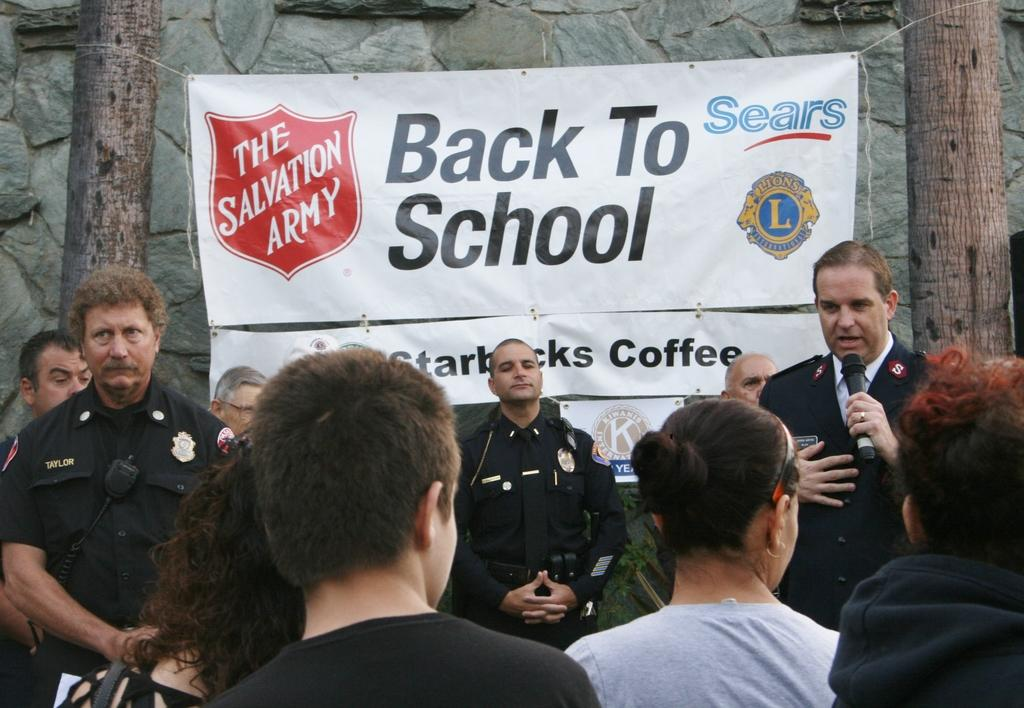How many people are in the image? There is a group of people in the image. What is the man holding among the group doing? The man holding a microphone among the group is likely speaking or performing. What can be seen in the background of the image? There is a banner, tree trunks, and a wall visible in the background of the image. Where is the badge located in the image? There is no badge present in the image. How does the group of people slip down the cellar in the image? The group of people does not slip down a cellar in the image; they are standing or interacting with each other. 